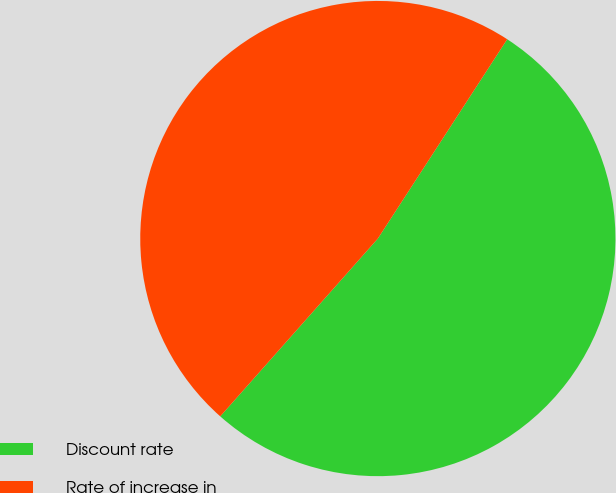Convert chart to OTSL. <chart><loc_0><loc_0><loc_500><loc_500><pie_chart><fcel>Discount rate<fcel>Rate of increase in<nl><fcel>52.38%<fcel>47.62%<nl></chart> 